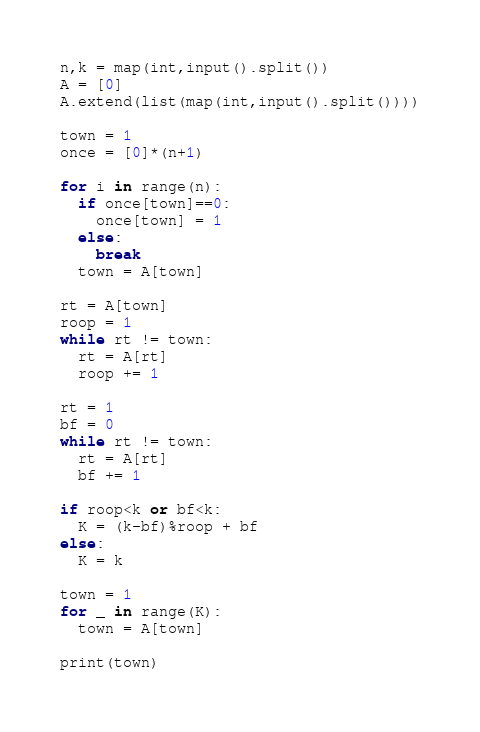<code> <loc_0><loc_0><loc_500><loc_500><_Python_>n,k = map(int,input().split())
A = [0]
A.extend(list(map(int,input().split())))

town = 1
once = [0]*(n+1)

for i in range(n):
  if once[town]==0:
    once[town] = 1
  else:
    break
  town = A[town]

rt = A[town]
roop = 1
while rt != town:
  rt = A[rt]
  roop += 1

rt = 1
bf = 0
while rt != town:
  rt = A[rt]
  bf += 1  

if roop<k or bf<k:
  K = (k-bf)%roop + bf
else:
  K = k

town = 1
for _ in range(K):
  town = A[town]

print(town)</code> 